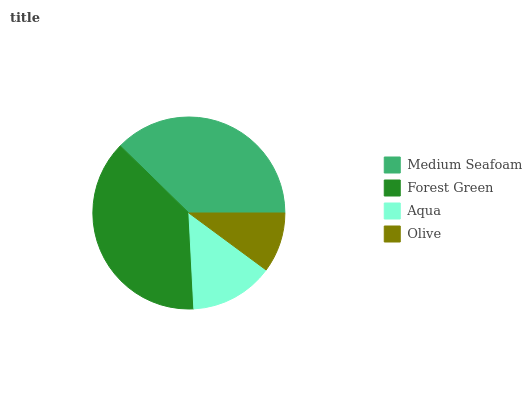Is Olive the minimum?
Answer yes or no. Yes. Is Forest Green the maximum?
Answer yes or no. Yes. Is Aqua the minimum?
Answer yes or no. No. Is Aqua the maximum?
Answer yes or no. No. Is Forest Green greater than Aqua?
Answer yes or no. Yes. Is Aqua less than Forest Green?
Answer yes or no. Yes. Is Aqua greater than Forest Green?
Answer yes or no. No. Is Forest Green less than Aqua?
Answer yes or no. No. Is Medium Seafoam the high median?
Answer yes or no. Yes. Is Aqua the low median?
Answer yes or no. Yes. Is Forest Green the high median?
Answer yes or no. No. Is Medium Seafoam the low median?
Answer yes or no. No. 